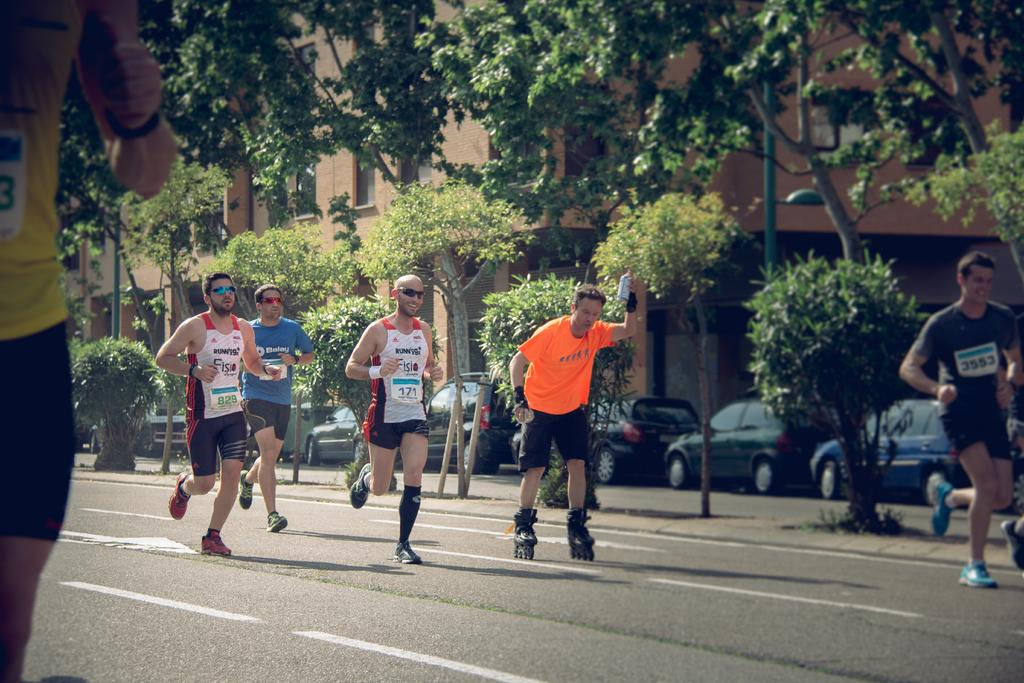What is the man in the image doing on the road? The man in the image is skating on the road. What are the other men in the image doing on the road? The other men in the image are running on the road. What can be seen in the background of the image? There are trees, vehicles, and buildings in the background of the image. What type of authority does the minister have in the image? There is no minister present in the image. How many legs does the man skating have in the image? The man skating has two legs, as humans typically have two legs. 